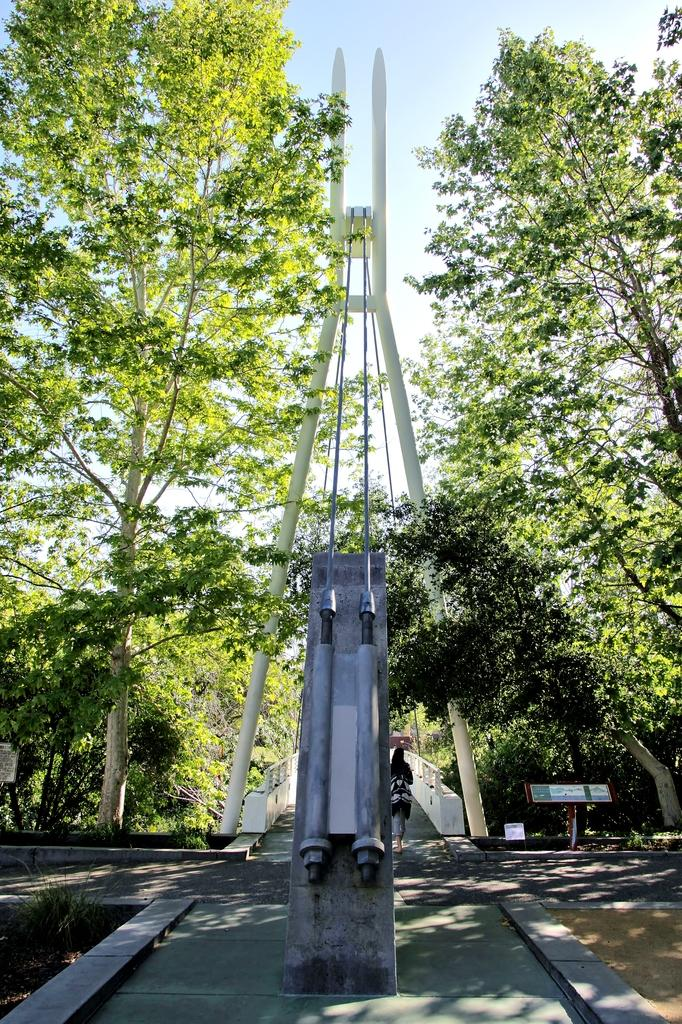What can be seen in the foreground of the image? There is a path to walk in the foreground of the image. What is located in the background of the image? There is a rope bridge and trees in the background of the image. What is the woman in the image doing? The woman is walking on the path in the background of the image. What is visible in the sky in the image? The sky is visible in the background of the image. How much salt is present on the rope bridge in the image? There is no salt present on the rope bridge in the image. What type of question is being asked in the image? There is no question being asked in the image; it is a visual representation of a scene. 